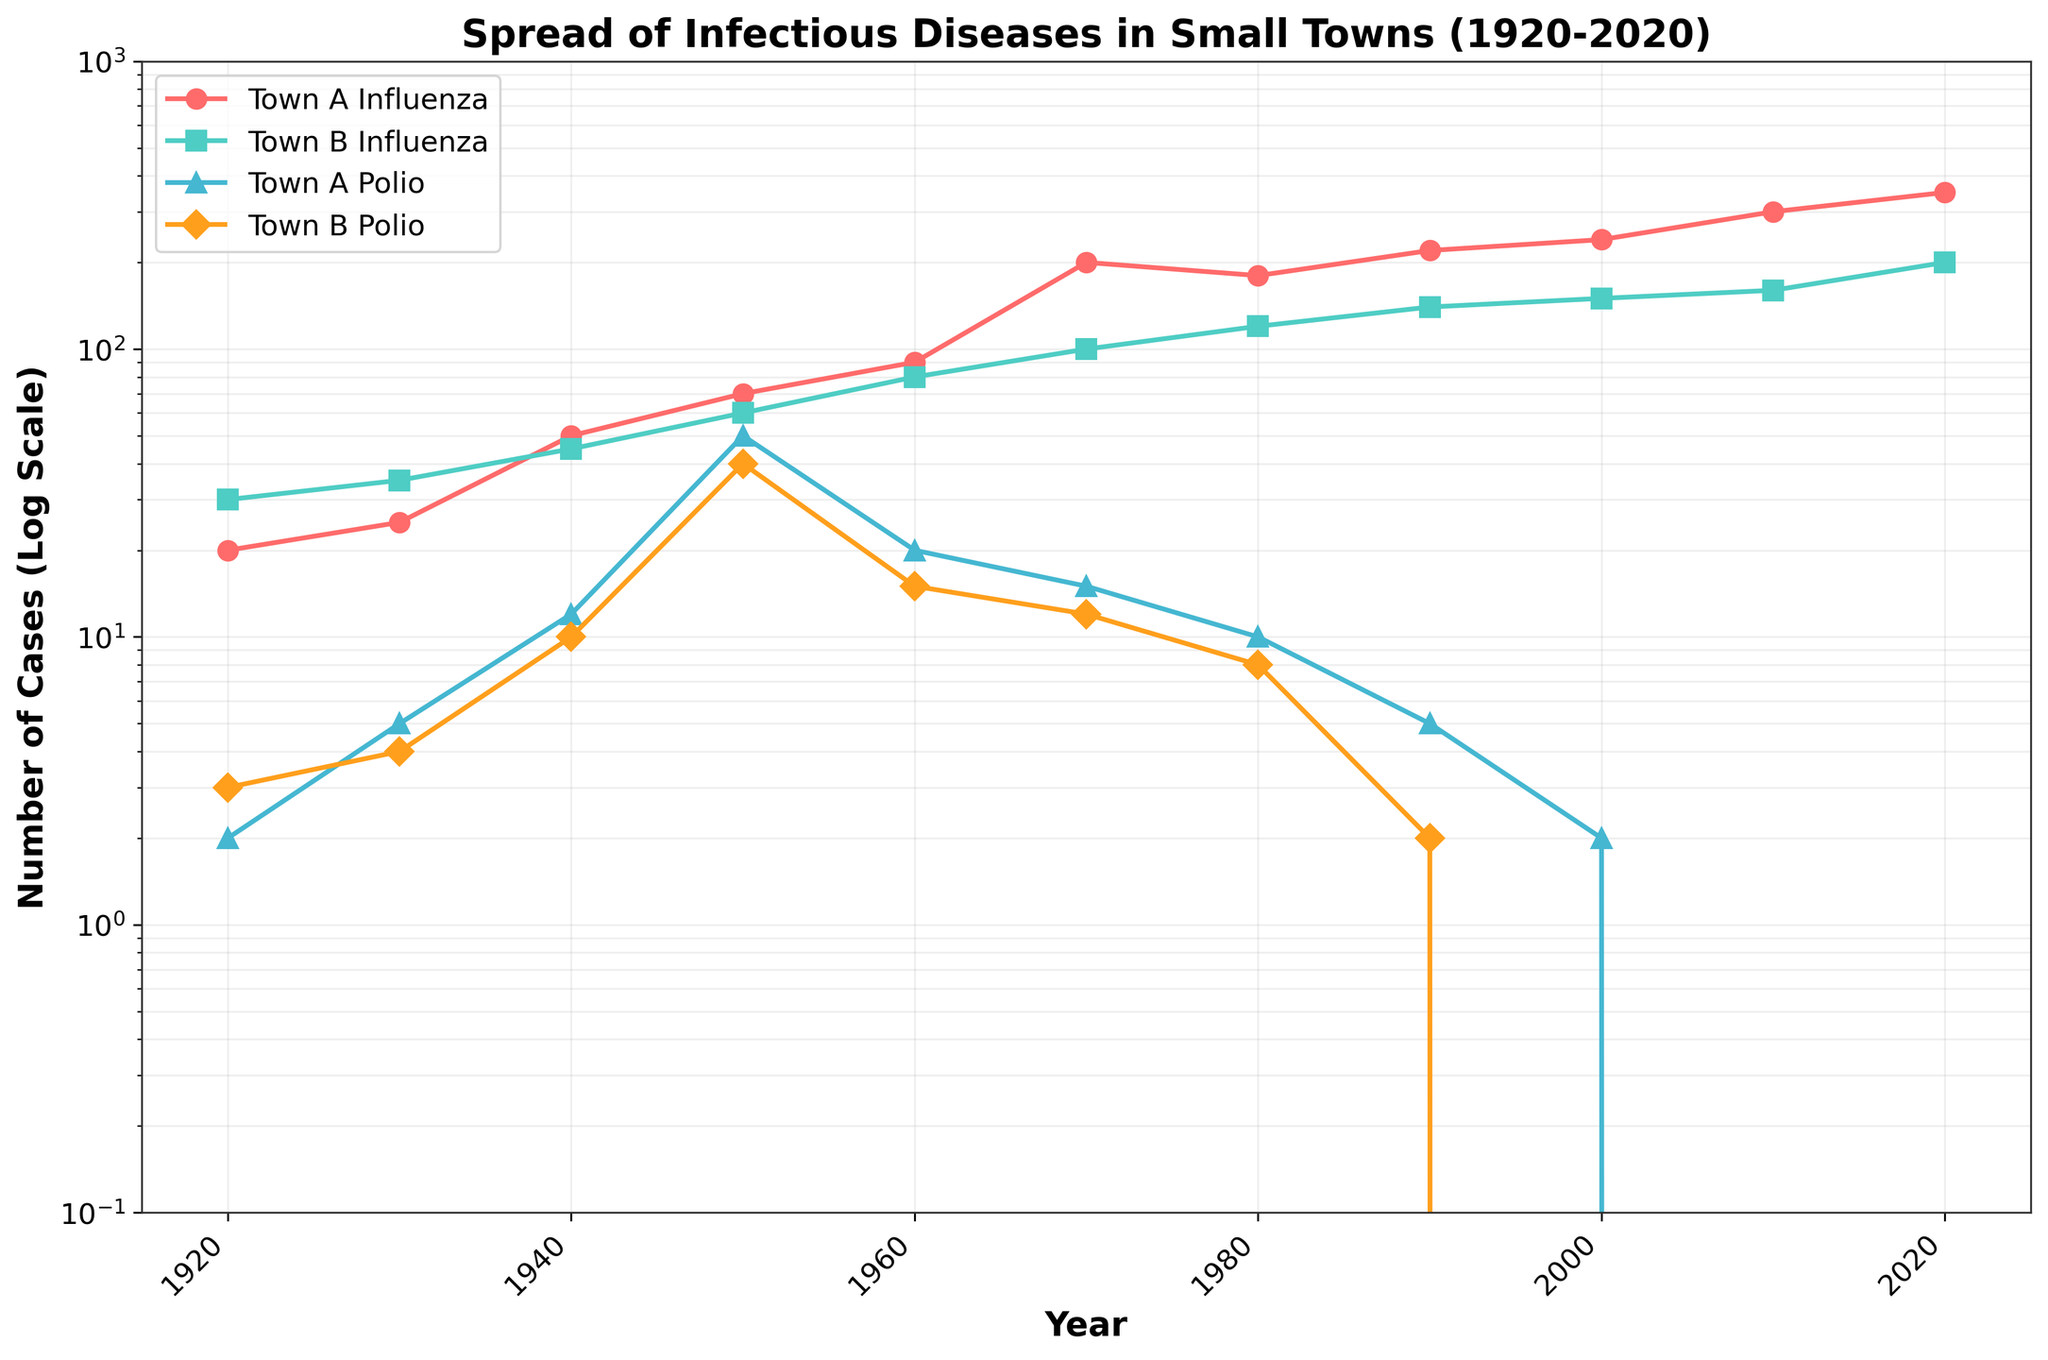What is the title of the figure? The title of the figure is located directly above the plot. It provides a high-level summary of what the figure represents.
Answer: Spread of Infectious Diseases in Small Towns (1920-2020) What does the y-axis represent? The y-axis represents the number of cases on a logarithmic scale, which allows exponential growth values to be visualized more easily.
Answer: Number of Cases (Log Scale) Which town had the highest number of influenza cases in 2020? By looking at the data points for 2020, we see that Town A has the highest number of influenza cases, represented by the red circles on the top of the plot.
Answer: Town A How many times did Town B exceed Town A in influenza cases between 1920 and 2020? We need to count the years when the green squares (Town B Influenza) are above the red circles (Town A Influenza). This happens in 1940, 1950, and 1980.
Answer: 3 times Did the number of polio cases in both towns decrease to zero by 2020? By looking at the data points for 2020, both the blue triangles (Town A Polio) and orange diamonds (Town B Polio) are at the bottom, indicating zero cases.
Answer: Yes Which year marks the highest peak in influenza cases for Town B? By following the green squares upwards, we find that the highest point is in the year 2020.
Answer: 2020 By how much did the influenza cases increase in Town A from 1920 to 1950? In 1920, Town A had 20 influenza cases; in 1950, it had 70. The difference is 70 - 20 = 50 cases.
Answer: 50 cases Which town had a more significant decrease in polio cases from 1950 to 1970? Town A had a decrease from 50 to 15 cases, a drop of 35. Town B decreased from 40 to 12 cases, a drop of 28. Comparing these two values, Town A had a larger decrease.
Answer: Town A In which year did Town A have double the number of polio cases compared to Town B? We find the years where the blue triangles (Town A Polio) are approximately double the orange diamonds (Town B Polio). In 1950, Town A had 50 cases, and Town B had 25 cases, which is a 5 and 2 ratio.
Answer: 1950 